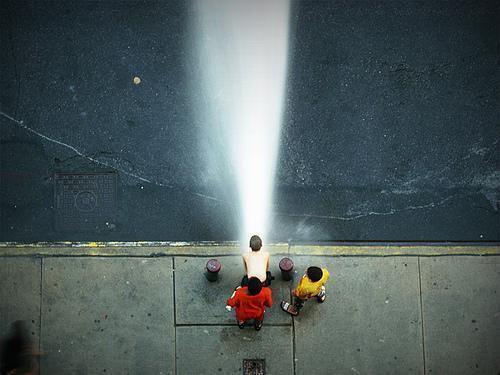How many children are there?
Give a very brief answer. 3. How many motorcycles in the picture?
Give a very brief answer. 0. 